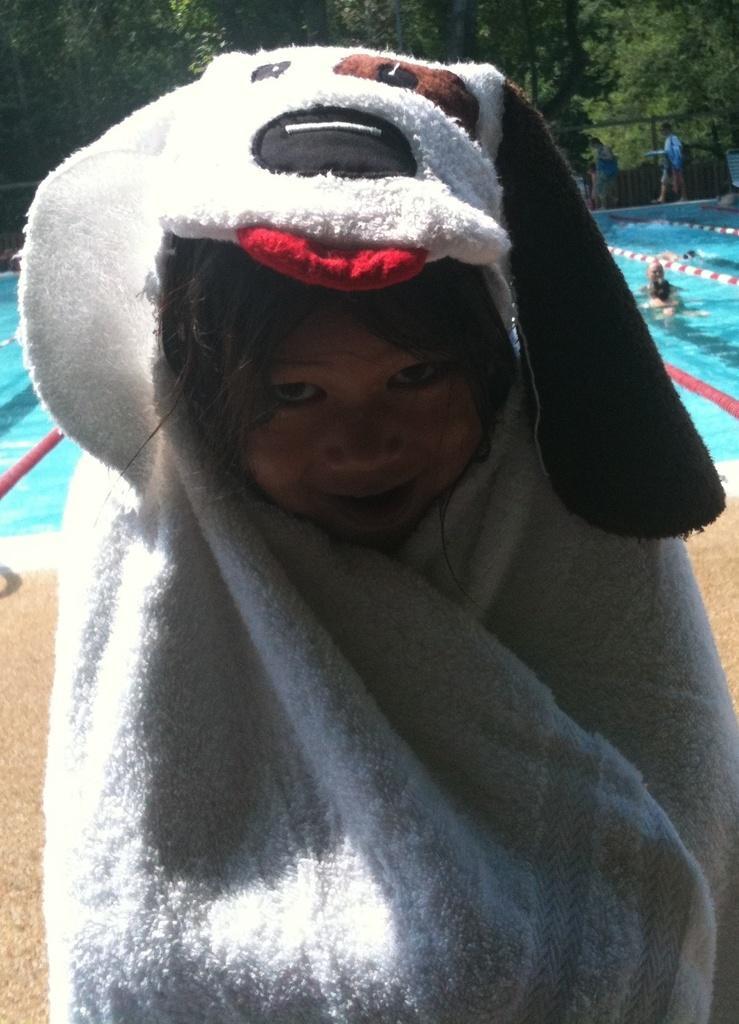How would you summarize this image in a sentence or two? In this picture we can see a child smiling with a towel and in the background we can see some people, water, trees and some objects. 